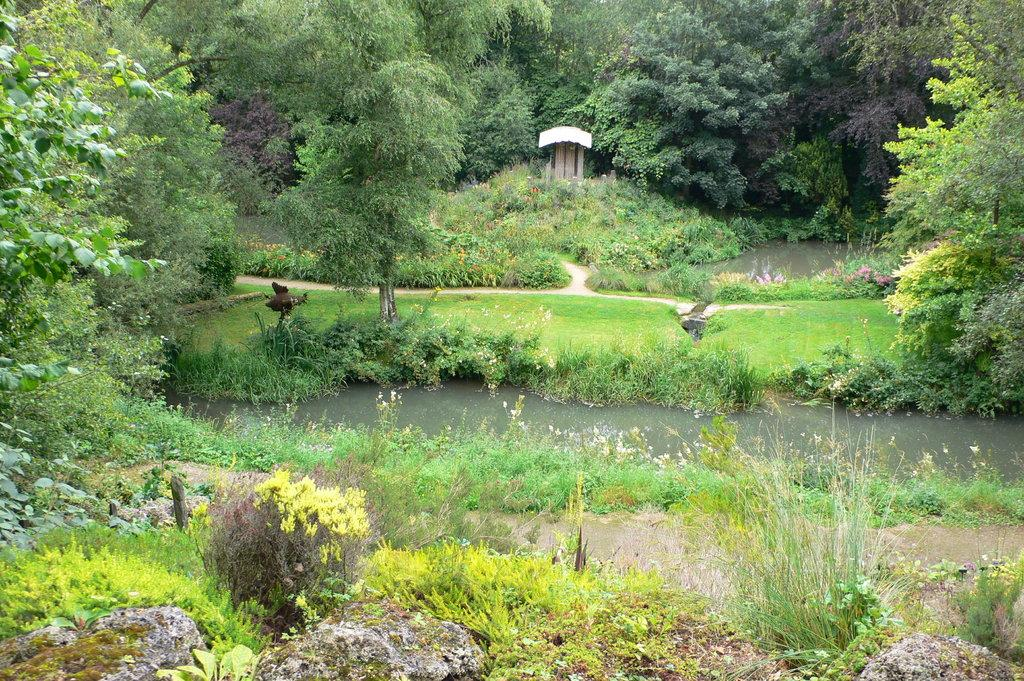What type of vegetation can be seen in the image? There are trees in the image. What type of water feature is present in the image? There is a canal in the image. How is the canal positioned in relation to the plants? The canal is between plants in the image. What other body of water can be seen in the image? There is a pond on the right side of the image. What type of pie is being served at the picnic table in the image? There is no picnic table or pie present in the image. What part of the canal is visible in the image? The canal is visible in its entirety in the image, as it is between plants. 